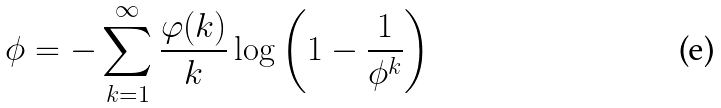<formula> <loc_0><loc_0><loc_500><loc_500>\phi = - \sum _ { k = 1 } ^ { \infty } { \frac { \varphi ( k ) } { k } } \log \left ( 1 - { \frac { 1 } { \phi ^ { k } } } \right )</formula> 